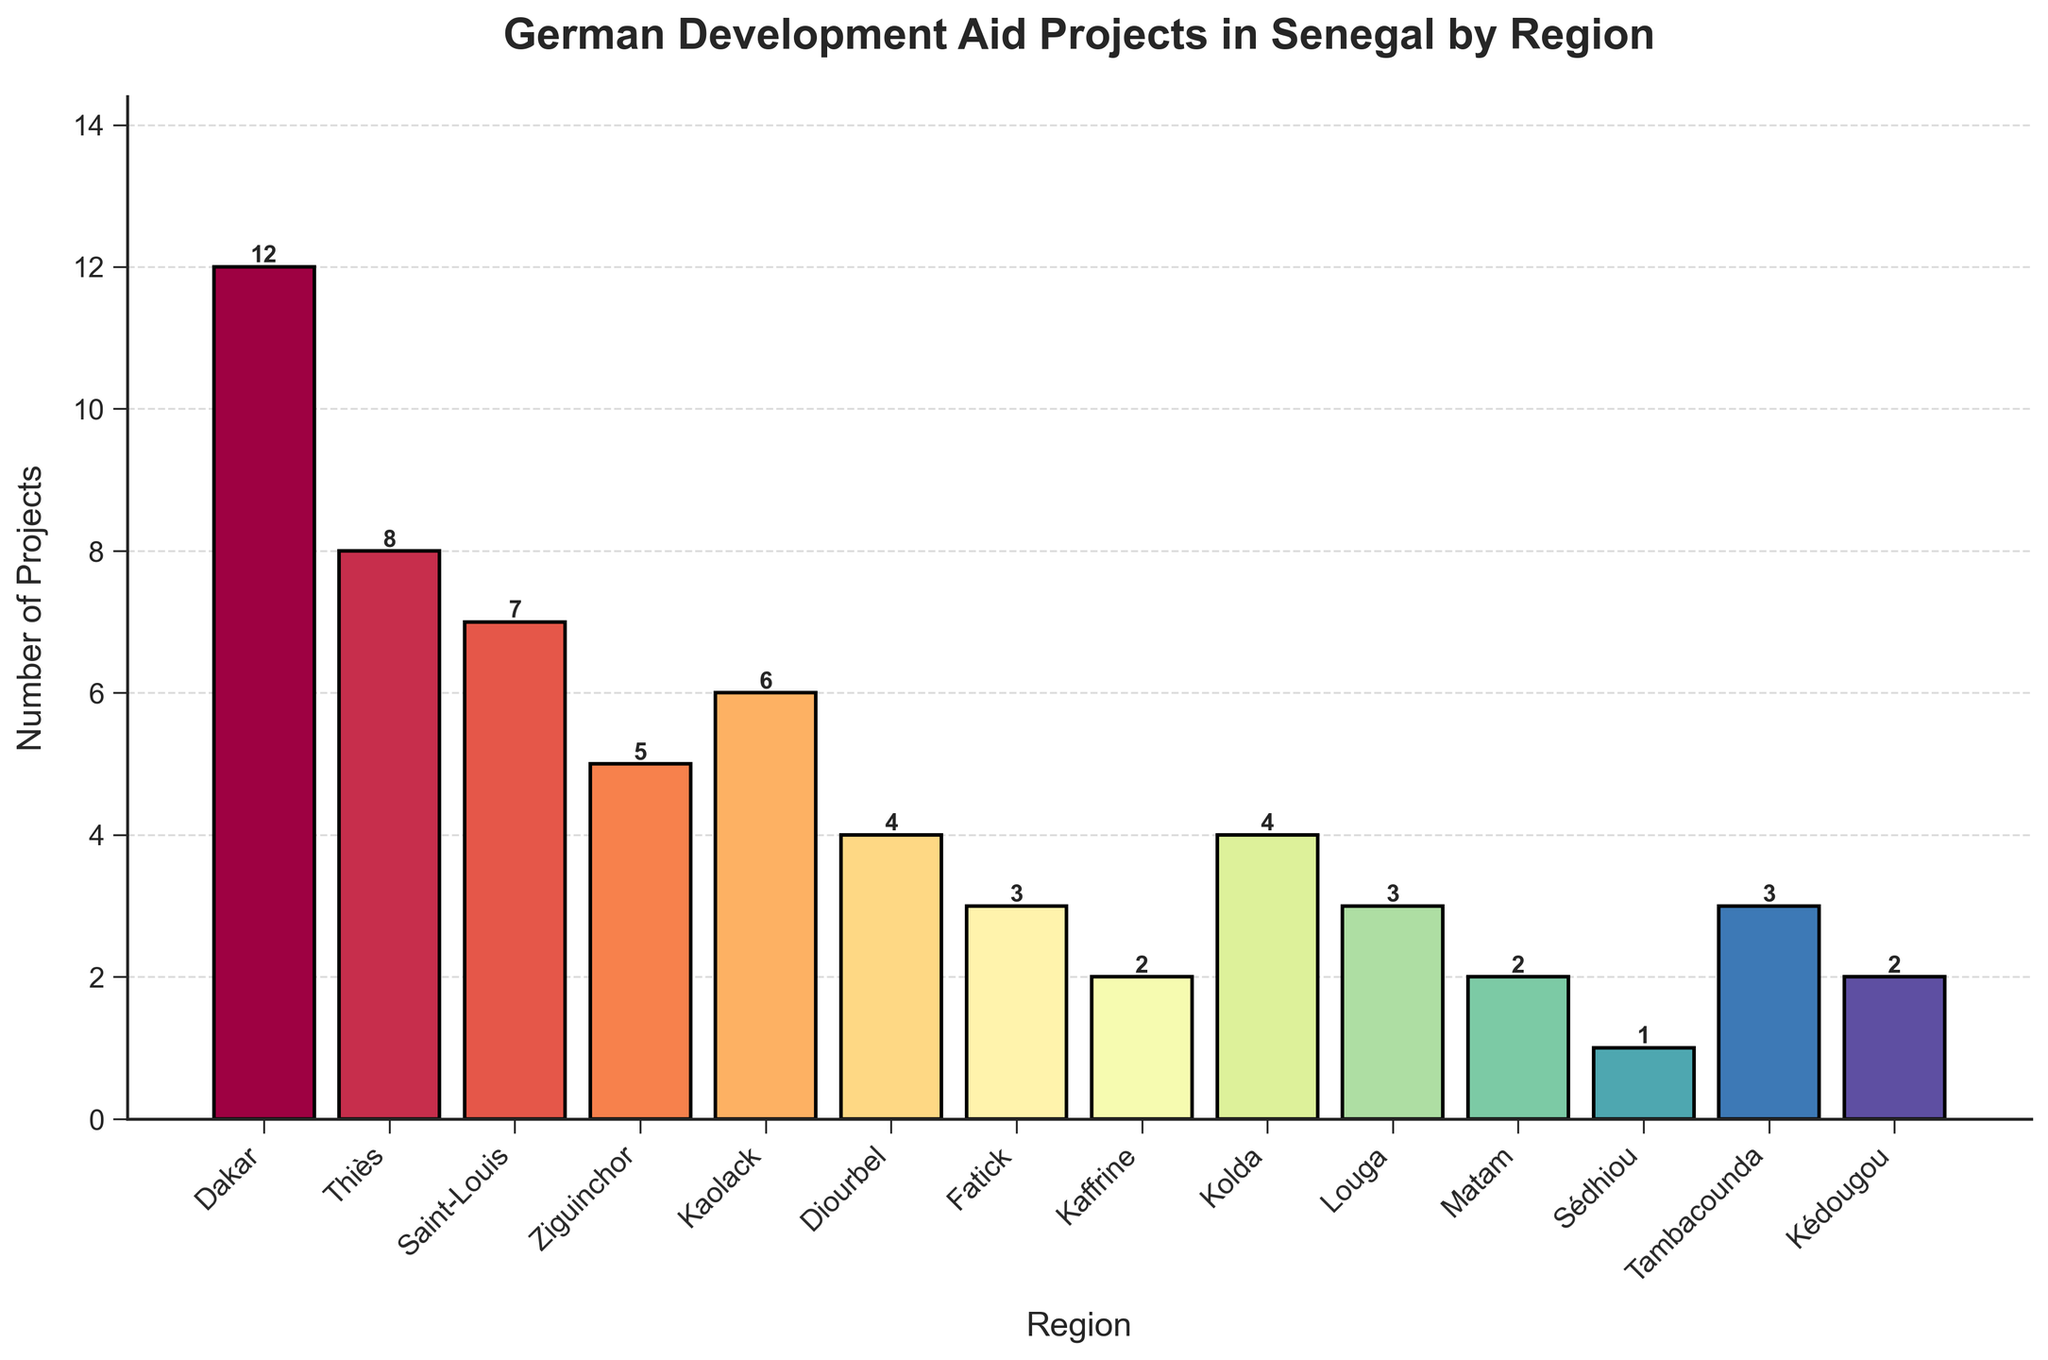Which region has the highest number of development aid projects? The bar chart shows the number of development aid projects per region, with the highest bar representing the region with the most projects. The highest bar belongs to Dakar.
Answer: Dakar How many development aid projects are there in total across all regions? To find the total number of projects, sum the number of projects in all regions: 12 (Dakar) + 8 (Thiès) + 7 (Saint-Louis) + 5 (Ziguinchor) + 6 (Kaolack) + 4 (Diourbel) + 3 (Fatick) + 2 (Kaffrine) + 4 (Kolda) + 3 (Louga) + 2 (Matam) + 1 (Sédhiou) + 3 (Tambacounda) + 2 (Kédougou) = 58.
Answer: 58 Which regions have fewer than 3 development aid projects? By observing the bar heights, the regions with heights corresponding to fewer than 3 projects are Kaffrine, Matam, and Sédhiou.
Answer: Kaffrine, Matam, Sédhiou What is the difference in the number of development aid projects between Dakar and Thiès? Dakar has 12 projects and Thiès has 8 projects. The difference is 12 - 8 = 4.
Answer: 4 Are there any regions with an equal number of development aid projects? If so, which ones? By comparing the bar heights, Diourbel and Kolda both have 4 projects each; Fatick, Louga, and Tambacounda each have 3 projects; and Matam and Kédougou each have 2 projects.
Answer: Diourbel & Kolda; Fatick & Louga & Tambacounda; Matam & Kédougou What is the average number of development aid projects per region? To find the average, sum the total number of projects and divide by the number of regions. Total projects = 58, number of regions = 14, so the average is 58 / 14 ≈ 4.14.
Answer: 4.14 Which region has the third highest number of development aid projects and how many projects does it have? The regions can be ordered by the number of projects: Dakar (12), Thiès (8), Saint-Louis (7). The third highest is Saint-Louis with 7 projects.
Answer: Saint-Louis, 7 How many more projects does Dakar have compared to the sum of projects in Kaffrine, Matam, and Kédougou? Dakar has 12 projects. Kaffrine, Matam, and Kédougou have 2 + 2 + 2 = 6 projects in total. The difference is 12 - 6 = 6.
Answer: 6 What is the combined number of projects in Saint-Louis, Ziguinchor, and Kaolack? Saint-Louis has 7 projects, Ziguinchor has 5, and Kaolack has 6. The combined number is 7 + 5 + 6 = 18.
Answer: 18 Does any region have exactly half the number of projects as Dakar? Dakar has 12 projects; half of 12 is 6. Kaolack has exactly 6 projects.
Answer: Kaolack 